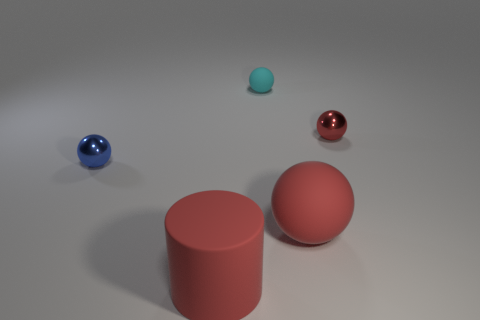What is the size of the shiny ball that is right of the tiny thing that is to the left of the big cylinder?
Provide a succinct answer. Small. There is a large thing that is the same color as the big rubber ball; what is it made of?
Provide a succinct answer. Rubber. There is a red ball that is in front of the tiny thing right of the cyan ball; are there any tiny blue shiny things that are in front of it?
Provide a succinct answer. No. Do the big red object in front of the large sphere and the red sphere behind the small blue ball have the same material?
Ensure brevity in your answer.  No. What number of things are either cyan matte spheres or tiny metal spheres on the right side of the small cyan object?
Offer a very short reply. 2. How many blue metallic things have the same shape as the small cyan object?
Offer a terse response. 1. What is the material of the cyan thing that is the same size as the red metal thing?
Give a very brief answer. Rubber. There is a red matte thing on the right side of the large thing on the left side of the big red object on the right side of the big matte cylinder; what size is it?
Ensure brevity in your answer.  Large. There is a small metallic sphere behind the blue metallic thing; is its color the same as the matte sphere that is in front of the cyan thing?
Your answer should be compact. Yes. What number of cyan things are matte cylinders or tiny metallic objects?
Give a very brief answer. 0. 